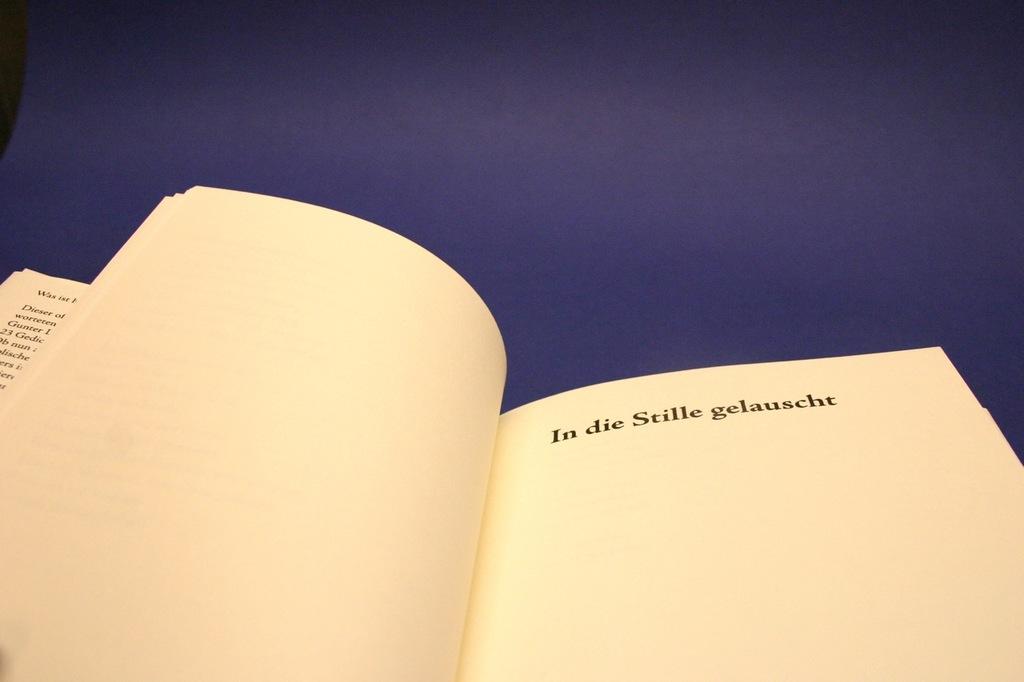What does the page say?
Your answer should be compact. In die stille gelauscht. What is the last word in the sentence?
Provide a short and direct response. Gelauscht. 